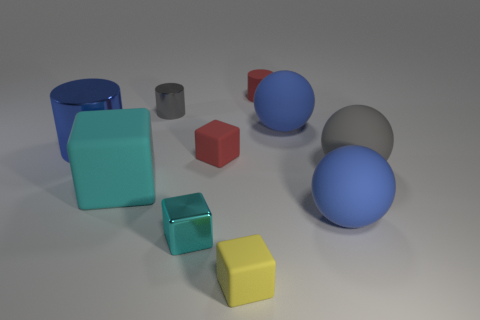Subtract all large gray rubber balls. How many balls are left? 2 Subtract all cyan spheres. How many cyan cubes are left? 2 Subtract all red cylinders. How many cylinders are left? 2 Add 6 blue cylinders. How many blue cylinders are left? 7 Add 8 small yellow matte things. How many small yellow matte things exist? 9 Subtract 0 green blocks. How many objects are left? 10 Subtract all cubes. How many objects are left? 6 Subtract 1 spheres. How many spheres are left? 2 Subtract all red blocks. Subtract all gray balls. How many blocks are left? 3 Subtract all small purple rubber balls. Subtract all rubber things. How many objects are left? 3 